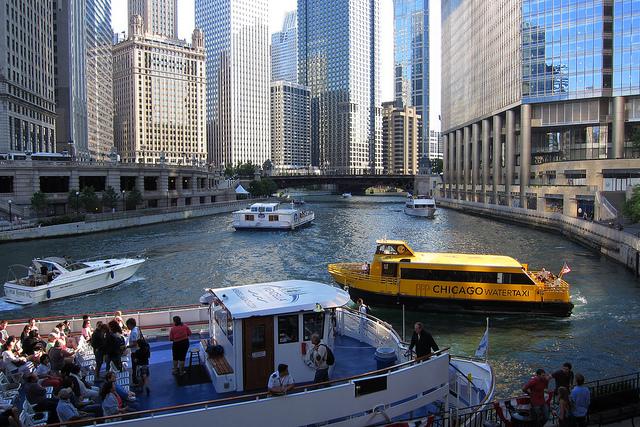How many buildings do you see?
Quick response, please. 11. What city is it?
Give a very brief answer. Chicago. What boat has the word "Chicago"?
Give a very brief answer. Yellow one. 